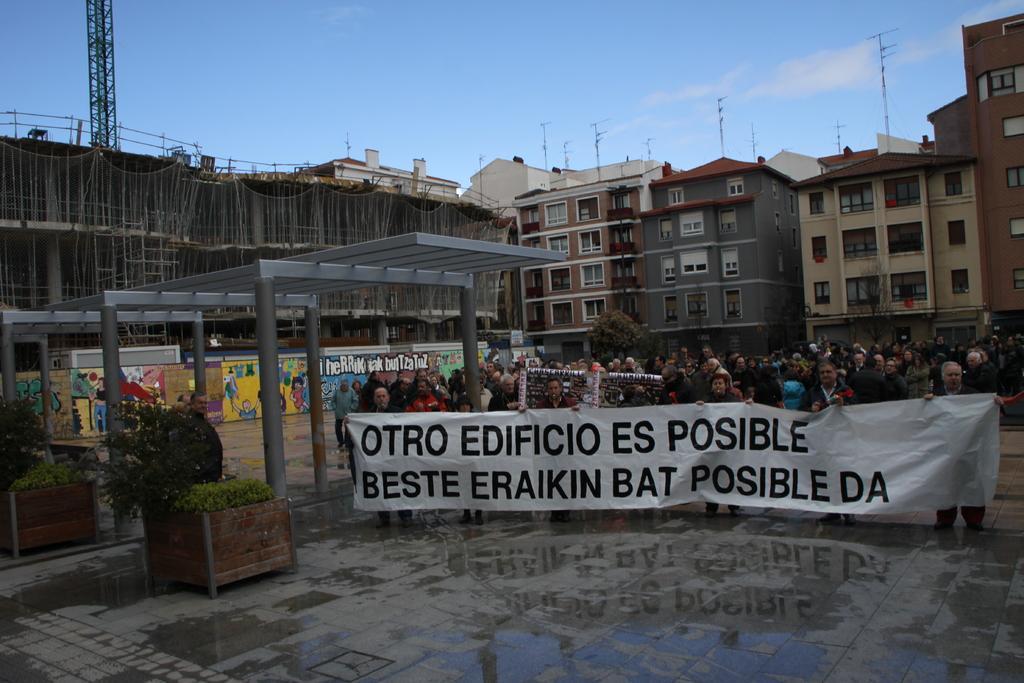Please provide a concise description of this image. In this image I can see the ground, some water on the ground, few plants which are green in color and number of persons are standing and holding a huge banner which is white and black in color. In the background I can see few buildings, few trees, few antennas, a tower and the sky. 